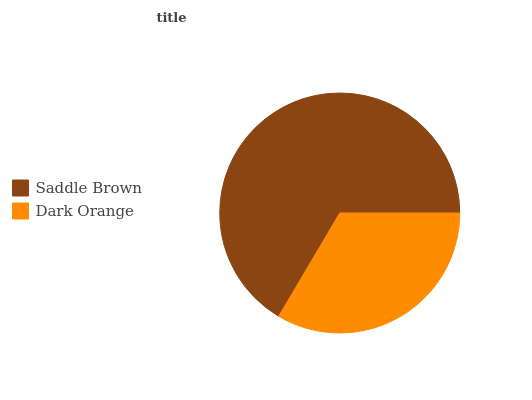Is Dark Orange the minimum?
Answer yes or no. Yes. Is Saddle Brown the maximum?
Answer yes or no. Yes. Is Dark Orange the maximum?
Answer yes or no. No. Is Saddle Brown greater than Dark Orange?
Answer yes or no. Yes. Is Dark Orange less than Saddle Brown?
Answer yes or no. Yes. Is Dark Orange greater than Saddle Brown?
Answer yes or no. No. Is Saddle Brown less than Dark Orange?
Answer yes or no. No. Is Saddle Brown the high median?
Answer yes or no. Yes. Is Dark Orange the low median?
Answer yes or no. Yes. Is Dark Orange the high median?
Answer yes or no. No. Is Saddle Brown the low median?
Answer yes or no. No. 